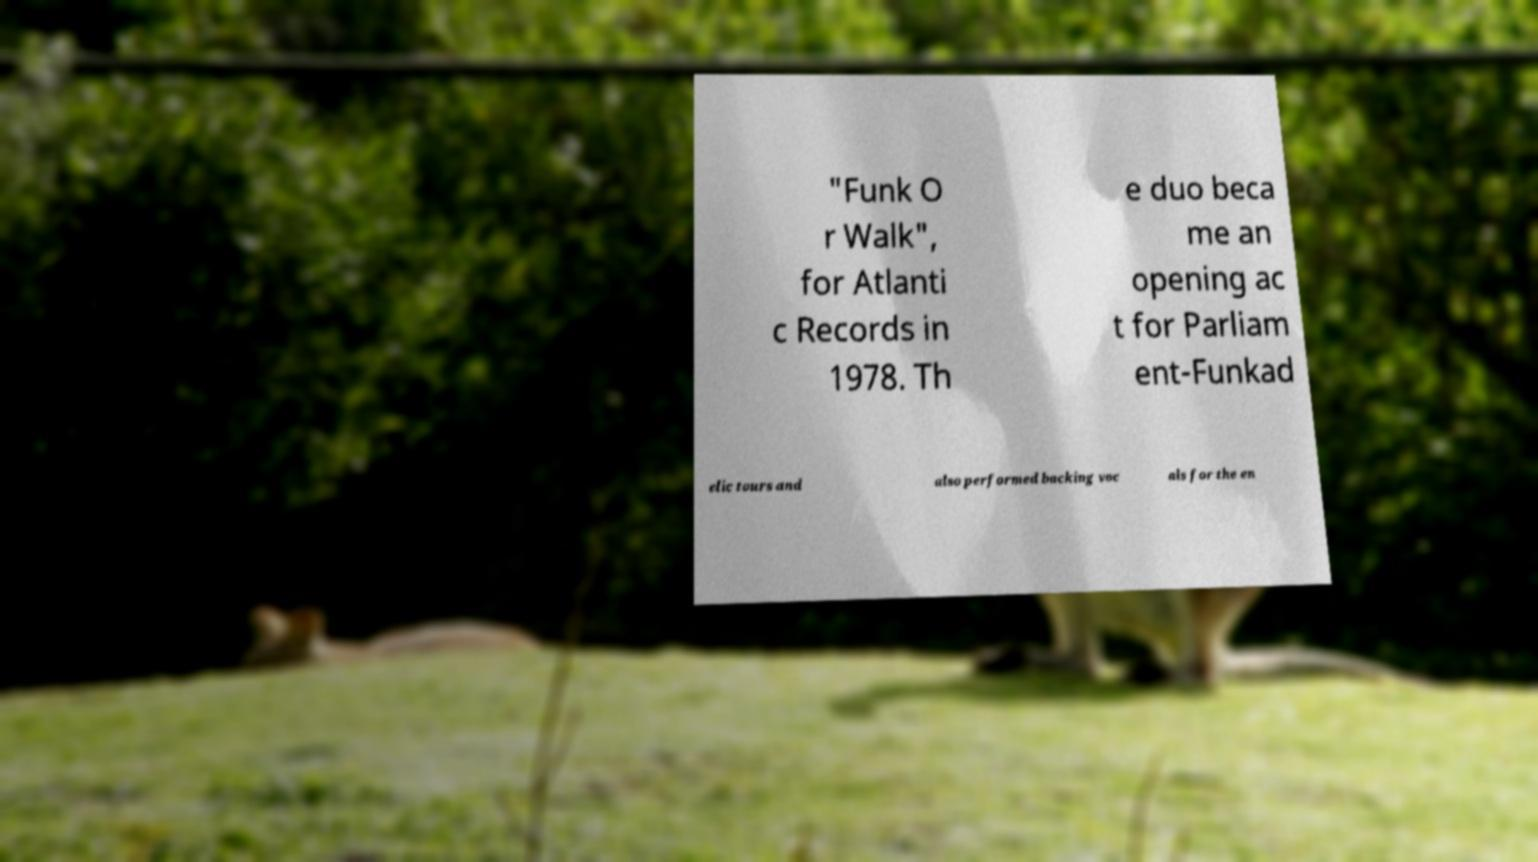Can you accurately transcribe the text from the provided image for me? "Funk O r Walk", for Atlanti c Records in 1978. Th e duo beca me an opening ac t for Parliam ent-Funkad elic tours and also performed backing voc als for the en 